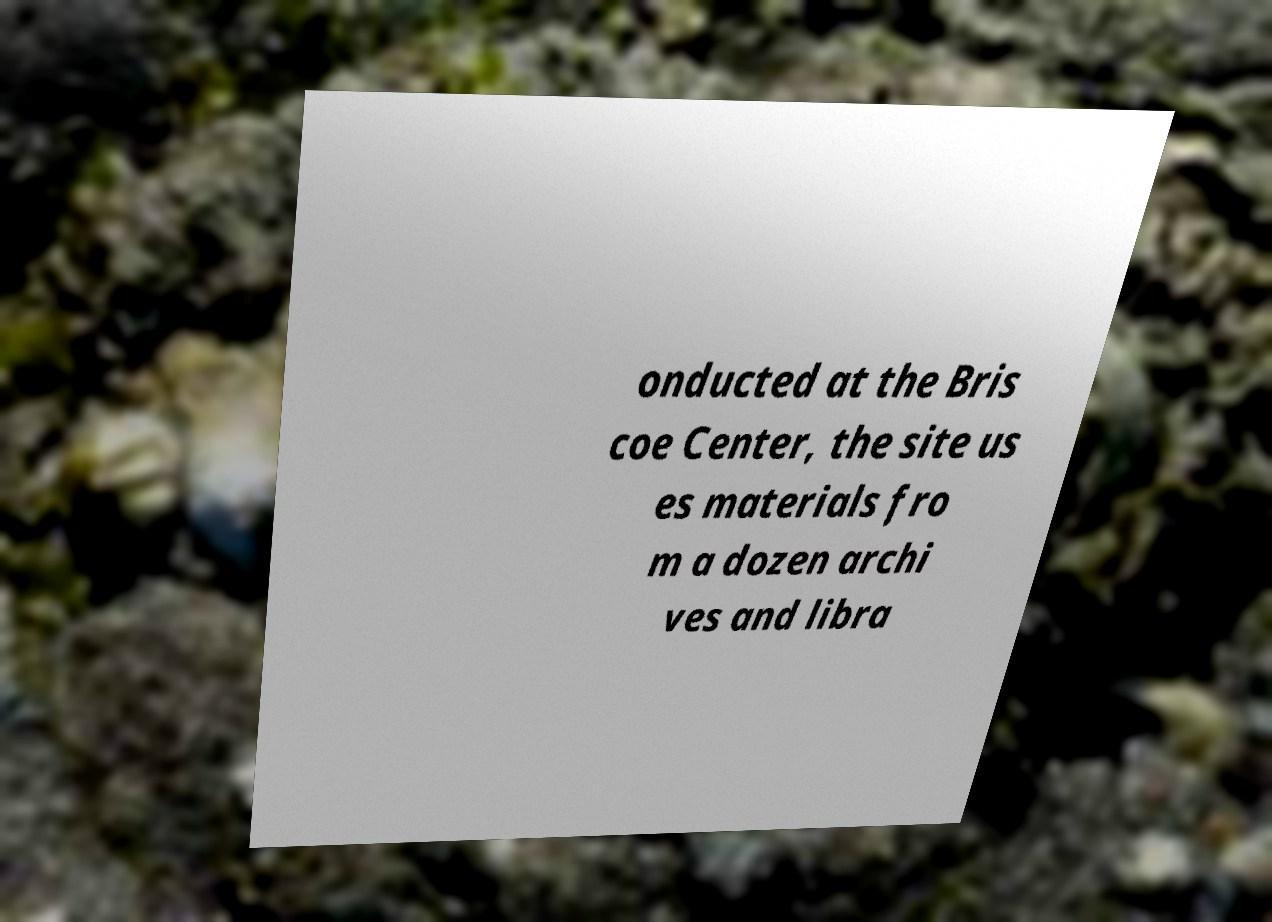What messages or text are displayed in this image? I need them in a readable, typed format. onducted at the Bris coe Center, the site us es materials fro m a dozen archi ves and libra 